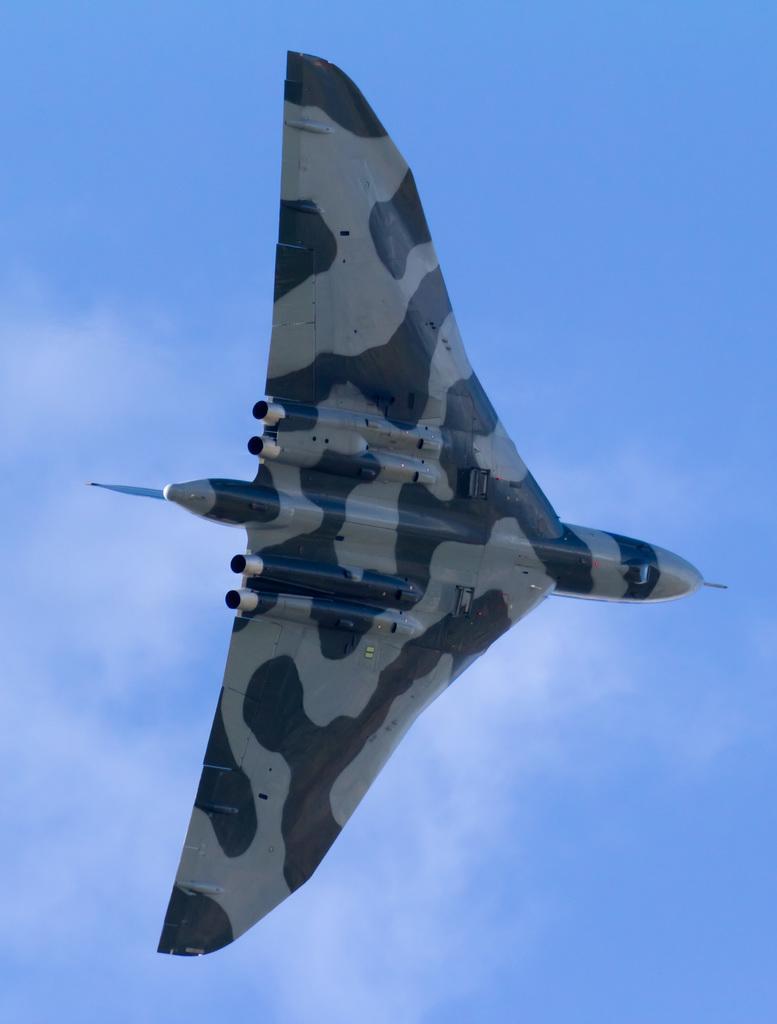Describe this image in one or two sentences. In this picture we can observe an airplane which is in black and white color flying in the air. In the background there is a sky with clouds. 